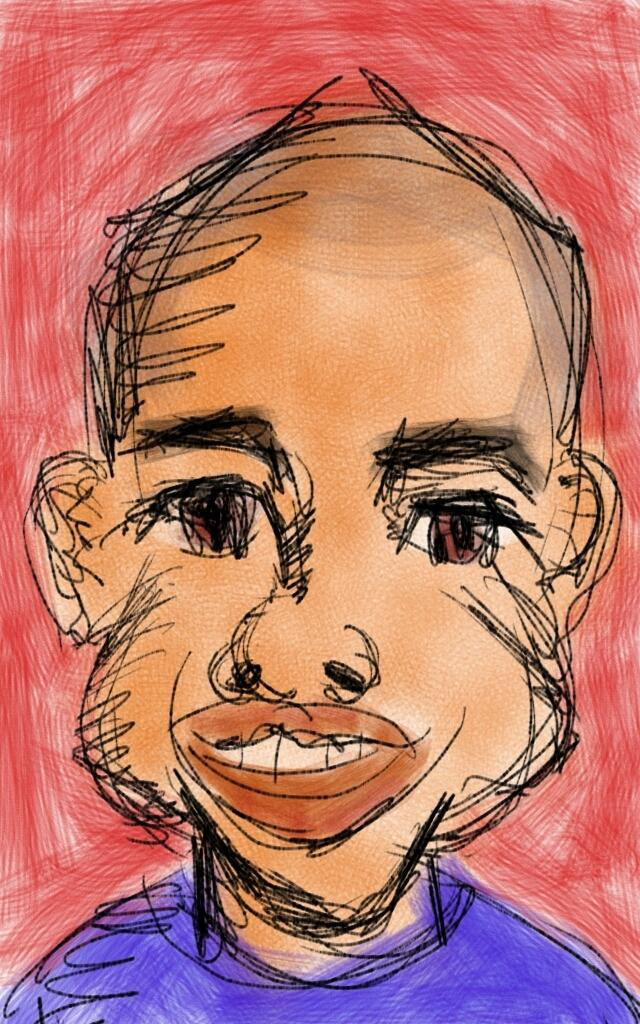What is the main subject of the image? There is a depiction of a person in the image. What color is the background of the image? The background of the image is red. How many flames can be seen surrounding the person in the image? There are no flames present in the image; it only depicts a person with a red background. 